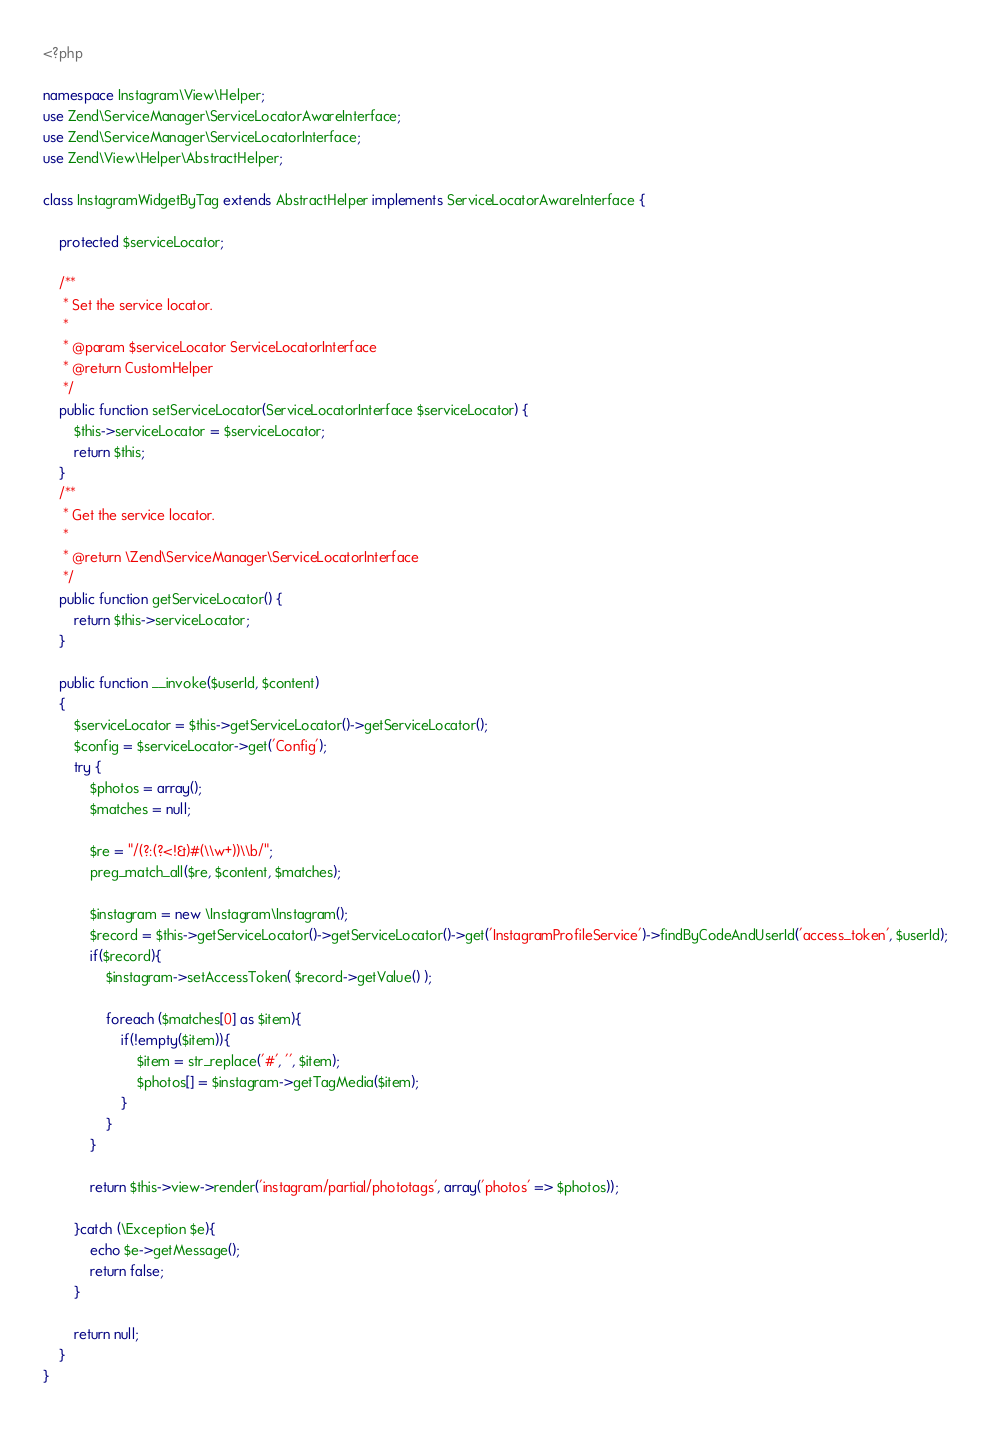Convert code to text. <code><loc_0><loc_0><loc_500><loc_500><_PHP_><?php 

namespace Instagram\View\Helper;
use Zend\ServiceManager\ServiceLocatorAwareInterface;
use Zend\ServiceManager\ServiceLocatorInterface;
use Zend\View\Helper\AbstractHelper;

class InstagramWidgetByTag extends AbstractHelper implements ServiceLocatorAwareInterface {
	
	protected $serviceLocator;
	 
	/**
	 * Set the service locator.
	 *
	 * @param $serviceLocator ServiceLocatorInterface       	
	 * @return CustomHelper
	 */
	public function setServiceLocator(ServiceLocatorInterface $serviceLocator) {
		$this->serviceLocator = $serviceLocator;
		return $this;
	}
	/**
	 * Get the service locator.
	 *
	 * @return \Zend\ServiceManager\ServiceLocatorInterface
	 */
	public function getServiceLocator() {
		return $this->serviceLocator;
	}
	
    public function __invoke($userId, $content)
    {
        $serviceLocator = $this->getServiceLocator()->getServiceLocator();
        $config = $serviceLocator->get('Config');
        try {
            $photos = array();
            $matches = null;
            
            $re = "/(?:(?<!&)#(\\w+))\\b/"; 
            preg_match_all($re, $content, $matches);
            
            $instagram = new \Instagram\Instagram();
            $record = $this->getServiceLocator()->getServiceLocator()->get('InstagramProfileService')->findByCodeAndUserId('access_token', $userId);
            if($record){
                $instagram->setAccessToken( $record->getValue() );
                
                foreach ($matches[0] as $item){
                    if(!empty($item)){
                        $item = str_replace('#', '', $item);
                        $photos[] = $instagram->getTagMedia($item);
                    }
                }
            }
            
            return $this->view->render('instagram/partial/phototags', array('photos' => $photos));
            
        }catch (\Exception $e){
            echo $e->getMessage();
            return false;
        }
        
        return null;
    }
}</code> 